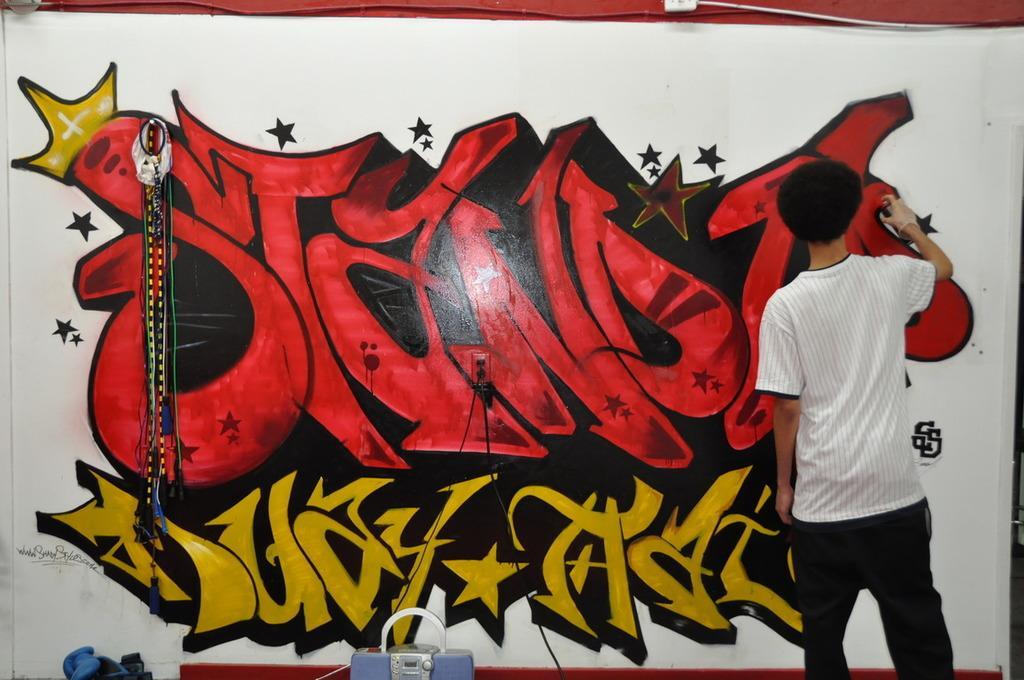Could you give a brief overview of what you see in this image? In the given picture, I can see a person holding a spray and painting the wall and i can see a tool kit and at the top right, We can see a wire an electrical wire and a box. 